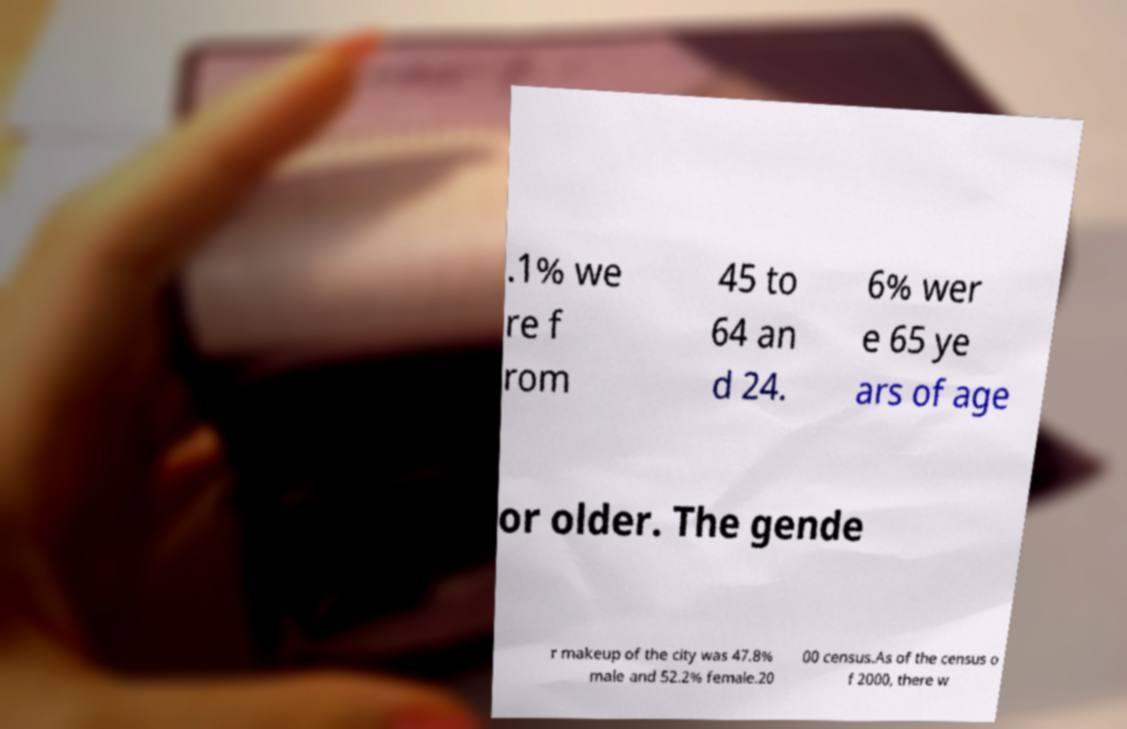Please identify and transcribe the text found in this image. .1% we re f rom 45 to 64 an d 24. 6% wer e 65 ye ars of age or older. The gende r makeup of the city was 47.8% male and 52.2% female.20 00 census.As of the census o f 2000, there w 